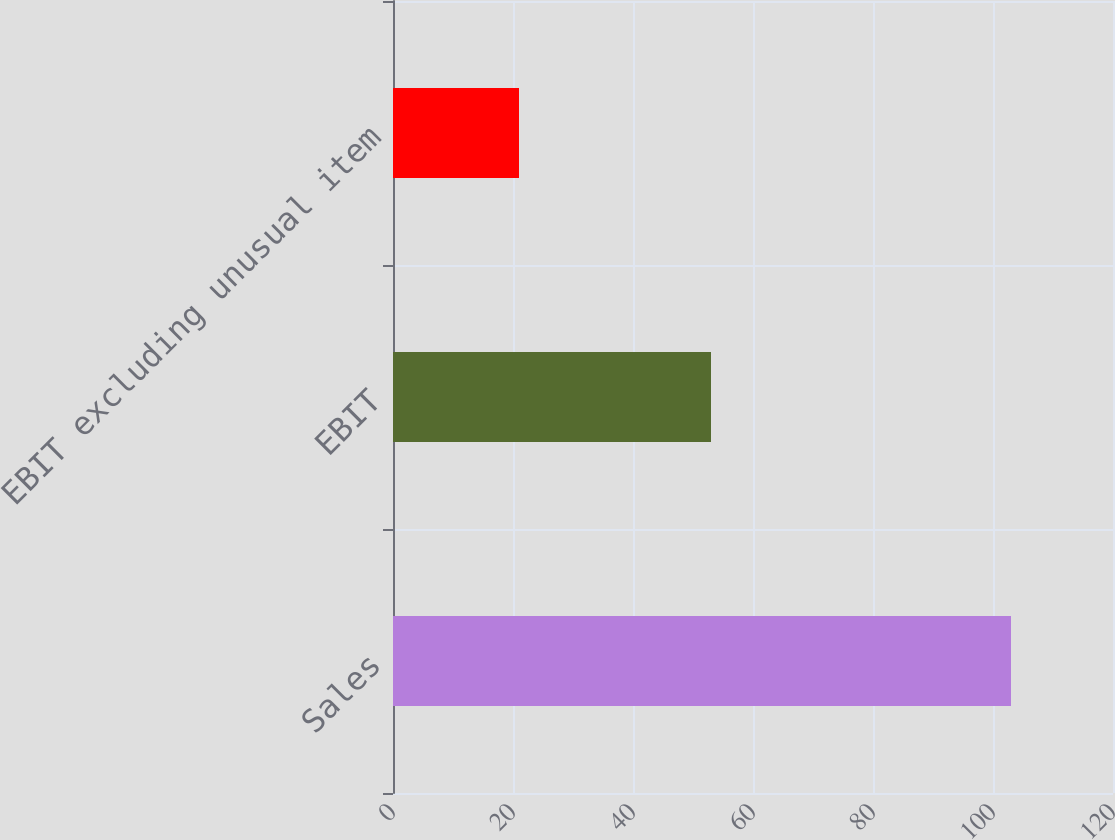Convert chart. <chart><loc_0><loc_0><loc_500><loc_500><bar_chart><fcel>Sales<fcel>EBIT<fcel>EBIT excluding unusual item<nl><fcel>103<fcel>53<fcel>21<nl></chart> 